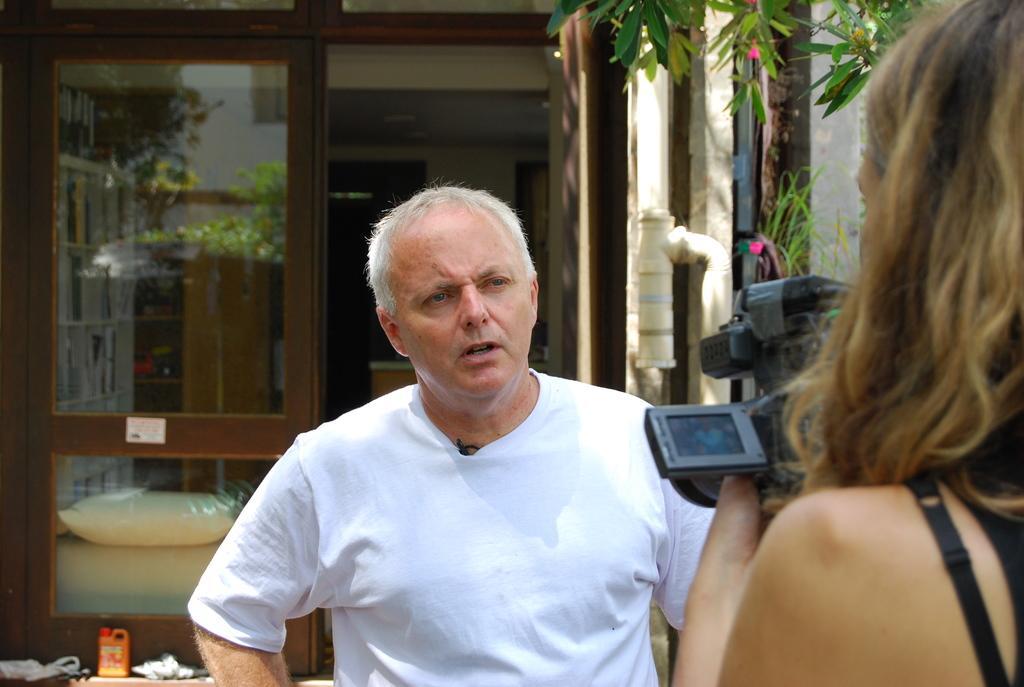Describe this image in one or two sentences. In this picture I can see a person holding a camera, there is a man standing, there are trees, this is looking like a house, these are looking like books in the racks, this is looking like a pillow and there are some other items. 